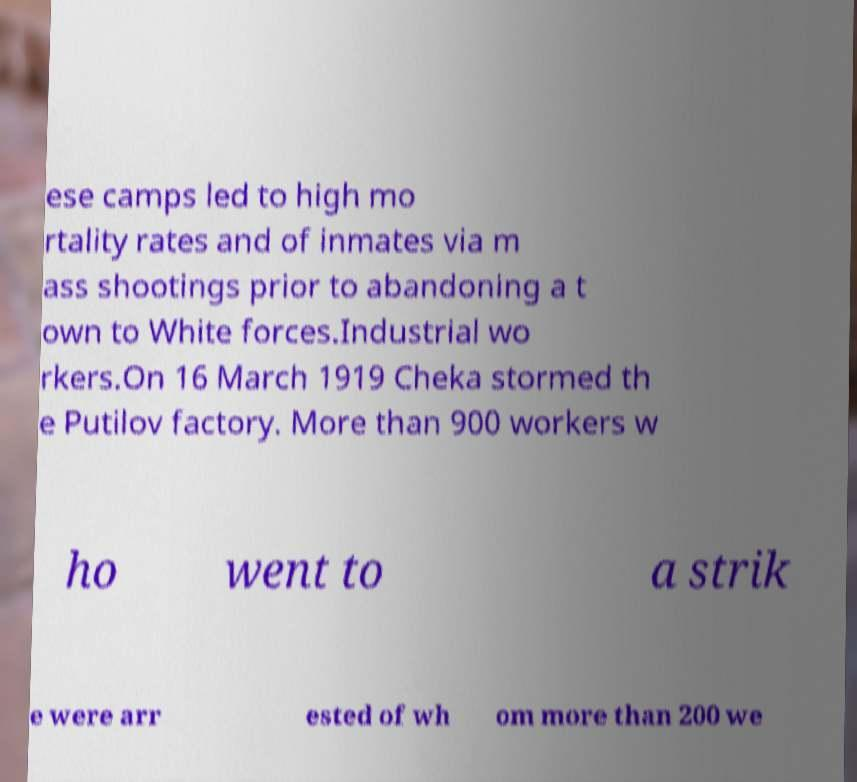Please read and relay the text visible in this image. What does it say? ese camps led to high mo rtality rates and of inmates via m ass shootings prior to abandoning a t own to White forces.Industrial wo rkers.On 16 March 1919 Cheka stormed th e Putilov factory. More than 900 workers w ho went to a strik e were arr ested of wh om more than 200 we 